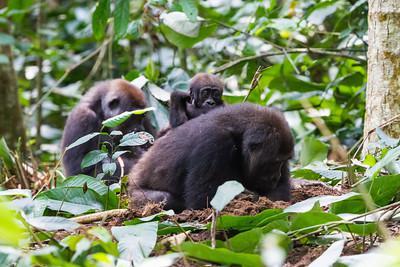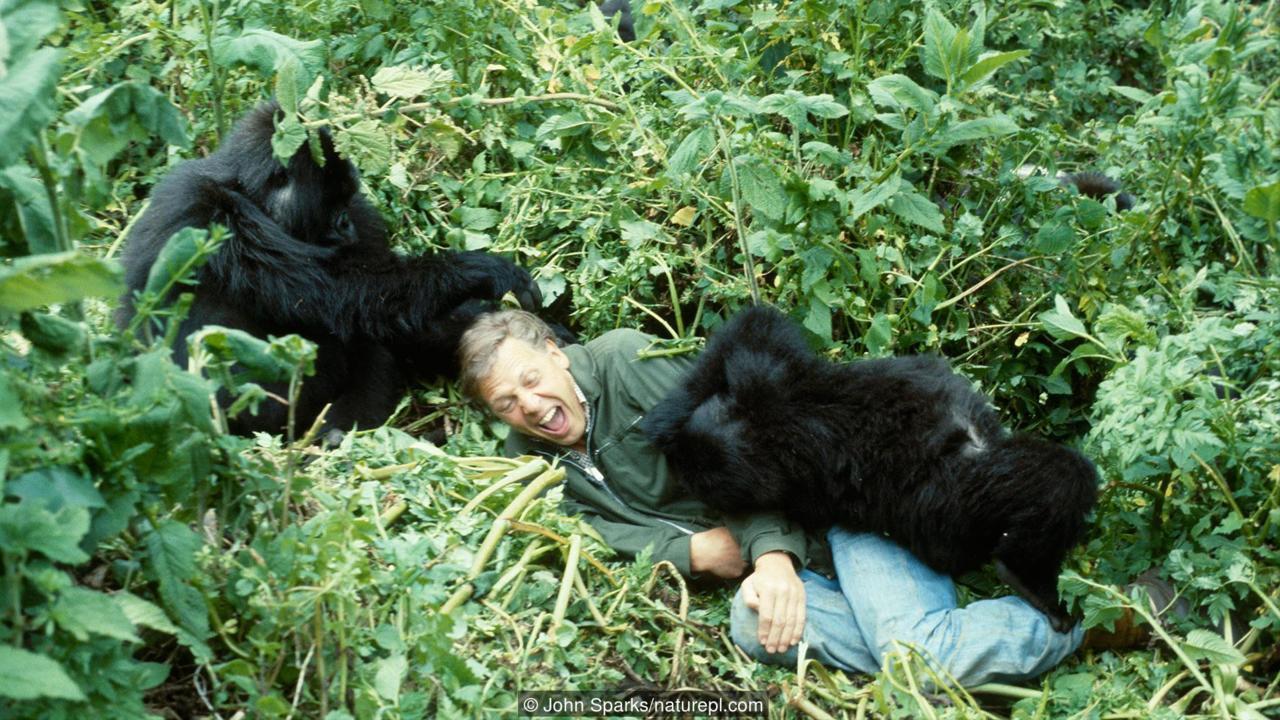The first image is the image on the left, the second image is the image on the right. Evaluate the accuracy of this statement regarding the images: "There are no more than five gorillas.". Is it true? Answer yes or no. Yes. The first image is the image on the left, the second image is the image on the right. Given the left and right images, does the statement "There are at least 6 gorillas in the right image." hold true? Answer yes or no. No. 